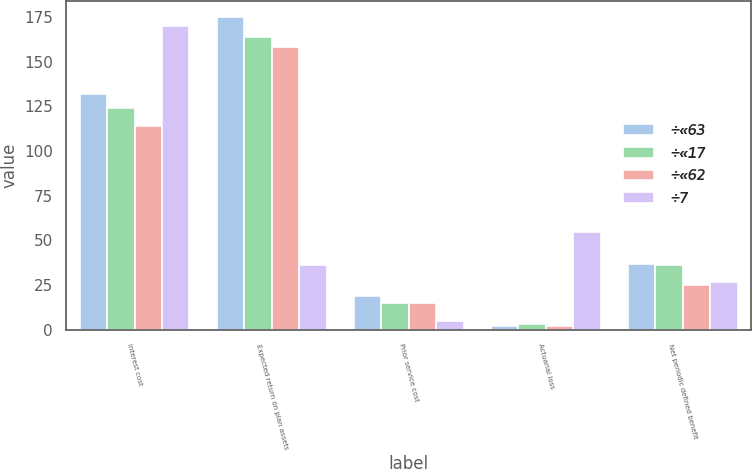<chart> <loc_0><loc_0><loc_500><loc_500><stacked_bar_chart><ecel><fcel>Interest cost<fcel>Expected return on plan assets<fcel>Prior service cost<fcel>Actuarial loss<fcel>Net periodic defined benefit<nl><fcel>÷«63<fcel>132<fcel>175<fcel>19<fcel>2<fcel>37<nl><fcel>÷«17<fcel>124<fcel>164<fcel>15<fcel>3<fcel>36<nl><fcel>÷«62<fcel>114<fcel>158<fcel>15<fcel>2<fcel>25<nl><fcel>÷7<fcel>170<fcel>36<fcel>5<fcel>55<fcel>27<nl></chart> 